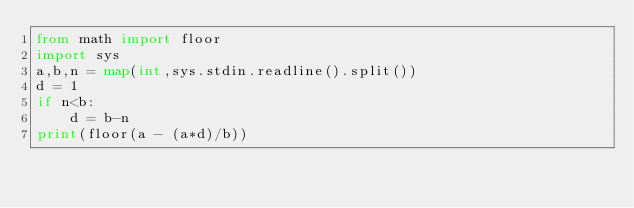<code> <loc_0><loc_0><loc_500><loc_500><_Python_>from math import floor
import sys
a,b,n = map(int,sys.stdin.readline().split())
d = 1
if n<b:
	d = b-n
print(floor(a - (a*d)/b))</code> 